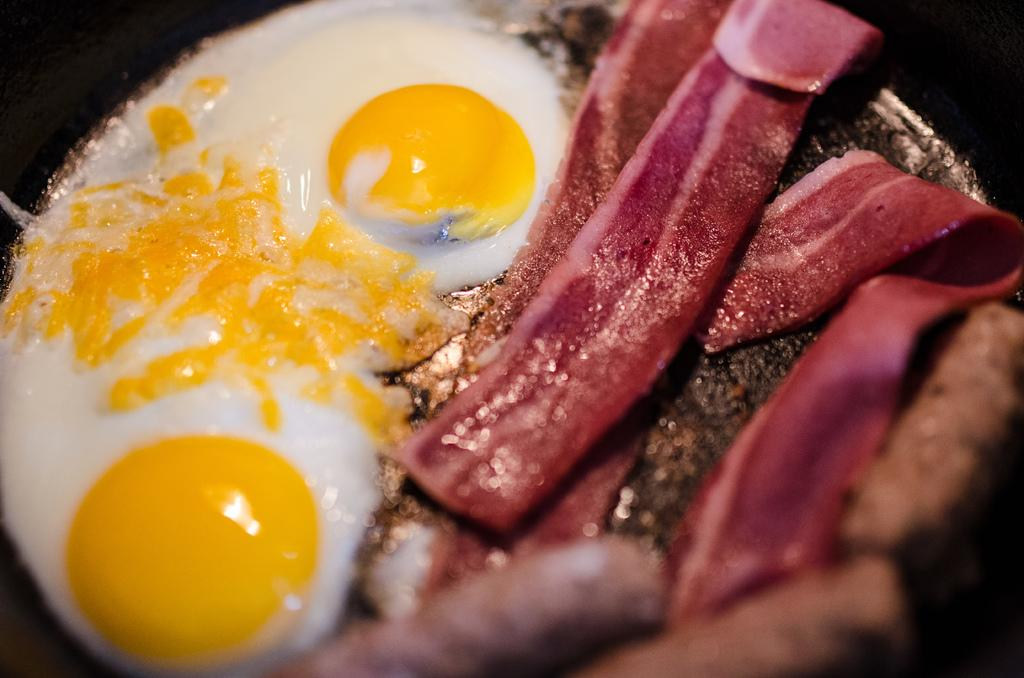What color is the bowl in the image? The bowl in the image is black colored. What is inside the bowl? The bowl contains a food item. Can you describe the colors of the food item? The food item has brown, red, cream, white, and yellow colors. What type of vessel is used to test the throat in the image? There is no vessel or test related to the throat present in the image. 